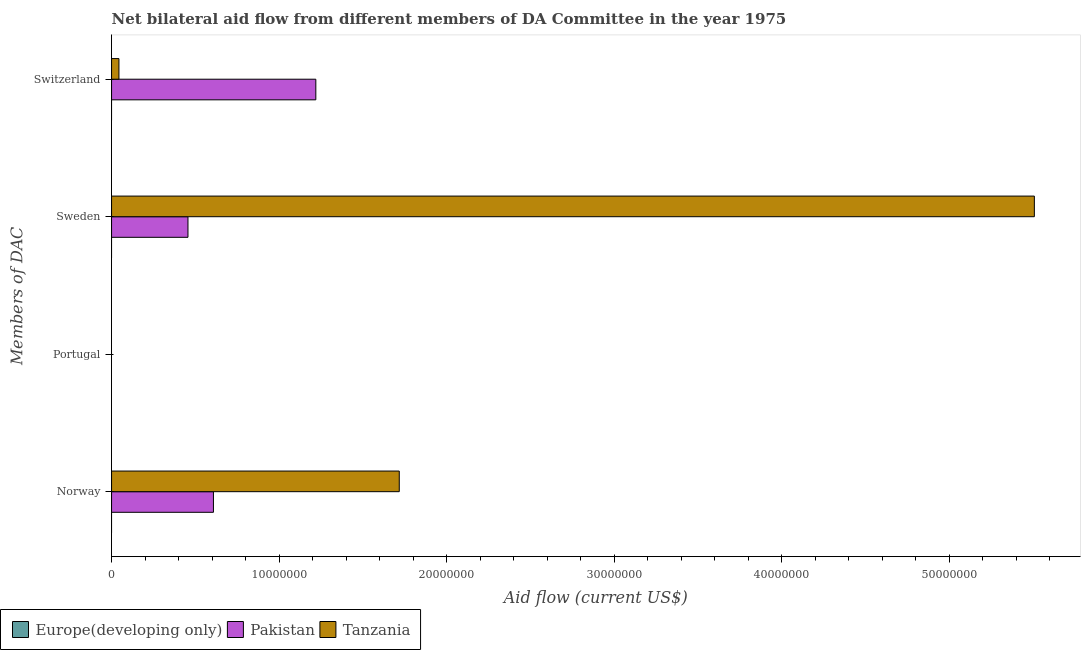Are the number of bars per tick equal to the number of legend labels?
Provide a short and direct response. No. How many bars are there on the 1st tick from the bottom?
Your response must be concise. 2. What is the label of the 1st group of bars from the top?
Offer a very short reply. Switzerland. Across all countries, what is the maximum amount of aid given by sweden?
Provide a short and direct response. 5.51e+07. In which country was the amount of aid given by norway maximum?
Make the answer very short. Tanzania. What is the total amount of aid given by norway in the graph?
Your answer should be compact. 2.32e+07. What is the difference between the amount of aid given by switzerland in Pakistan and that in Tanzania?
Ensure brevity in your answer.  1.18e+07. What is the difference between the amount of aid given by norway in Tanzania and the amount of aid given by portugal in Europe(developing only)?
Provide a short and direct response. 1.72e+07. What is the average amount of aid given by switzerland per country?
Provide a succinct answer. 4.21e+06. What is the difference between the amount of aid given by sweden and amount of aid given by switzerland in Tanzania?
Give a very brief answer. 5.46e+07. What is the difference between the highest and the lowest amount of aid given by norway?
Your answer should be compact. 1.72e+07. In how many countries, is the amount of aid given by switzerland greater than the average amount of aid given by switzerland taken over all countries?
Your answer should be very brief. 1. How many bars are there?
Offer a terse response. 9. Are all the bars in the graph horizontal?
Provide a succinct answer. Yes. What is the difference between two consecutive major ticks on the X-axis?
Give a very brief answer. 1.00e+07. Does the graph contain grids?
Offer a very short reply. No. Where does the legend appear in the graph?
Your answer should be very brief. Bottom left. How many legend labels are there?
Provide a succinct answer. 3. What is the title of the graph?
Your answer should be compact. Net bilateral aid flow from different members of DA Committee in the year 1975. Does "Curacao" appear as one of the legend labels in the graph?
Give a very brief answer. No. What is the label or title of the Y-axis?
Give a very brief answer. Members of DAC. What is the Aid flow (current US$) in Pakistan in Norway?
Ensure brevity in your answer.  6.08e+06. What is the Aid flow (current US$) of Tanzania in Norway?
Provide a short and direct response. 1.72e+07. What is the Aid flow (current US$) of Europe(developing only) in Portugal?
Your response must be concise. Nan. What is the Aid flow (current US$) in Pakistan in Portugal?
Offer a very short reply. Nan. What is the Aid flow (current US$) in Tanzania in Portugal?
Your answer should be compact. Nan. What is the Aid flow (current US$) in Pakistan in Sweden?
Keep it short and to the point. 4.56e+06. What is the Aid flow (current US$) of Tanzania in Sweden?
Your response must be concise. 5.51e+07. What is the Aid flow (current US$) in Europe(developing only) in Switzerland?
Keep it short and to the point. 0. What is the Aid flow (current US$) in Pakistan in Switzerland?
Provide a short and direct response. 1.22e+07. Across all Members of DAC, what is the maximum Aid flow (current US$) of Pakistan?
Make the answer very short. 1.22e+07. Across all Members of DAC, what is the maximum Aid flow (current US$) of Tanzania?
Offer a very short reply. 5.51e+07. Across all Members of DAC, what is the minimum Aid flow (current US$) in Pakistan?
Offer a terse response. 4.56e+06. What is the total Aid flow (current US$) of Pakistan in the graph?
Make the answer very short. 2.28e+07. What is the total Aid flow (current US$) in Tanzania in the graph?
Your answer should be very brief. 7.27e+07. What is the difference between the Aid flow (current US$) in Pakistan in Norway and that in Portugal?
Provide a succinct answer. Nan. What is the difference between the Aid flow (current US$) in Tanzania in Norway and that in Portugal?
Offer a very short reply. Nan. What is the difference between the Aid flow (current US$) in Pakistan in Norway and that in Sweden?
Keep it short and to the point. 1.52e+06. What is the difference between the Aid flow (current US$) in Tanzania in Norway and that in Sweden?
Your answer should be very brief. -3.79e+07. What is the difference between the Aid flow (current US$) in Pakistan in Norway and that in Switzerland?
Your response must be concise. -6.11e+06. What is the difference between the Aid flow (current US$) of Tanzania in Norway and that in Switzerland?
Offer a terse response. 1.67e+07. What is the difference between the Aid flow (current US$) of Pakistan in Portugal and that in Sweden?
Your answer should be very brief. Nan. What is the difference between the Aid flow (current US$) of Tanzania in Portugal and that in Sweden?
Offer a very short reply. Nan. What is the difference between the Aid flow (current US$) of Pakistan in Portugal and that in Switzerland?
Ensure brevity in your answer.  Nan. What is the difference between the Aid flow (current US$) of Tanzania in Portugal and that in Switzerland?
Provide a succinct answer. Nan. What is the difference between the Aid flow (current US$) of Pakistan in Sweden and that in Switzerland?
Your answer should be very brief. -7.63e+06. What is the difference between the Aid flow (current US$) of Tanzania in Sweden and that in Switzerland?
Your answer should be very brief. 5.46e+07. What is the difference between the Aid flow (current US$) in Pakistan in Norway and the Aid flow (current US$) in Tanzania in Portugal?
Offer a terse response. Nan. What is the difference between the Aid flow (current US$) of Pakistan in Norway and the Aid flow (current US$) of Tanzania in Sweden?
Ensure brevity in your answer.  -4.90e+07. What is the difference between the Aid flow (current US$) in Pakistan in Norway and the Aid flow (current US$) in Tanzania in Switzerland?
Offer a very short reply. 5.64e+06. What is the difference between the Aid flow (current US$) of Europe(developing only) in Portugal and the Aid flow (current US$) of Pakistan in Sweden?
Provide a succinct answer. Nan. What is the difference between the Aid flow (current US$) of Europe(developing only) in Portugal and the Aid flow (current US$) of Tanzania in Sweden?
Provide a short and direct response. Nan. What is the difference between the Aid flow (current US$) of Pakistan in Portugal and the Aid flow (current US$) of Tanzania in Sweden?
Your answer should be very brief. Nan. What is the difference between the Aid flow (current US$) of Europe(developing only) in Portugal and the Aid flow (current US$) of Pakistan in Switzerland?
Offer a very short reply. Nan. What is the difference between the Aid flow (current US$) of Europe(developing only) in Portugal and the Aid flow (current US$) of Tanzania in Switzerland?
Your answer should be very brief. Nan. What is the difference between the Aid flow (current US$) in Pakistan in Portugal and the Aid flow (current US$) in Tanzania in Switzerland?
Make the answer very short. Nan. What is the difference between the Aid flow (current US$) of Pakistan in Sweden and the Aid flow (current US$) of Tanzania in Switzerland?
Your answer should be compact. 4.12e+06. What is the average Aid flow (current US$) of Pakistan per Members of DAC?
Offer a terse response. 5.71e+06. What is the average Aid flow (current US$) of Tanzania per Members of DAC?
Your response must be concise. 1.82e+07. What is the difference between the Aid flow (current US$) in Pakistan and Aid flow (current US$) in Tanzania in Norway?
Provide a succinct answer. -1.11e+07. What is the difference between the Aid flow (current US$) in Europe(developing only) and Aid flow (current US$) in Pakistan in Portugal?
Your response must be concise. Nan. What is the difference between the Aid flow (current US$) of Europe(developing only) and Aid flow (current US$) of Tanzania in Portugal?
Offer a terse response. Nan. What is the difference between the Aid flow (current US$) of Pakistan and Aid flow (current US$) of Tanzania in Portugal?
Give a very brief answer. Nan. What is the difference between the Aid flow (current US$) of Pakistan and Aid flow (current US$) of Tanzania in Sweden?
Provide a succinct answer. -5.05e+07. What is the difference between the Aid flow (current US$) in Pakistan and Aid flow (current US$) in Tanzania in Switzerland?
Offer a terse response. 1.18e+07. What is the ratio of the Aid flow (current US$) of Pakistan in Norway to that in Portugal?
Make the answer very short. Nan. What is the ratio of the Aid flow (current US$) of Tanzania in Norway to that in Portugal?
Make the answer very short. Nan. What is the ratio of the Aid flow (current US$) of Tanzania in Norway to that in Sweden?
Your answer should be compact. 0.31. What is the ratio of the Aid flow (current US$) in Pakistan in Norway to that in Switzerland?
Make the answer very short. 0.5. What is the ratio of the Aid flow (current US$) in Tanzania in Norway to that in Switzerland?
Provide a succinct answer. 39.02. What is the ratio of the Aid flow (current US$) of Pakistan in Portugal to that in Sweden?
Your answer should be very brief. Nan. What is the ratio of the Aid flow (current US$) of Tanzania in Portugal to that in Sweden?
Your response must be concise. Nan. What is the ratio of the Aid flow (current US$) of Pakistan in Portugal to that in Switzerland?
Provide a succinct answer. Nan. What is the ratio of the Aid flow (current US$) of Tanzania in Portugal to that in Switzerland?
Your response must be concise. Nan. What is the ratio of the Aid flow (current US$) of Pakistan in Sweden to that in Switzerland?
Your response must be concise. 0.37. What is the ratio of the Aid flow (current US$) of Tanzania in Sweden to that in Switzerland?
Ensure brevity in your answer.  125.16. What is the difference between the highest and the second highest Aid flow (current US$) in Pakistan?
Keep it short and to the point. 6.11e+06. What is the difference between the highest and the second highest Aid flow (current US$) in Tanzania?
Give a very brief answer. 3.79e+07. What is the difference between the highest and the lowest Aid flow (current US$) of Pakistan?
Offer a very short reply. 7.63e+06. What is the difference between the highest and the lowest Aid flow (current US$) of Tanzania?
Offer a very short reply. 5.46e+07. 